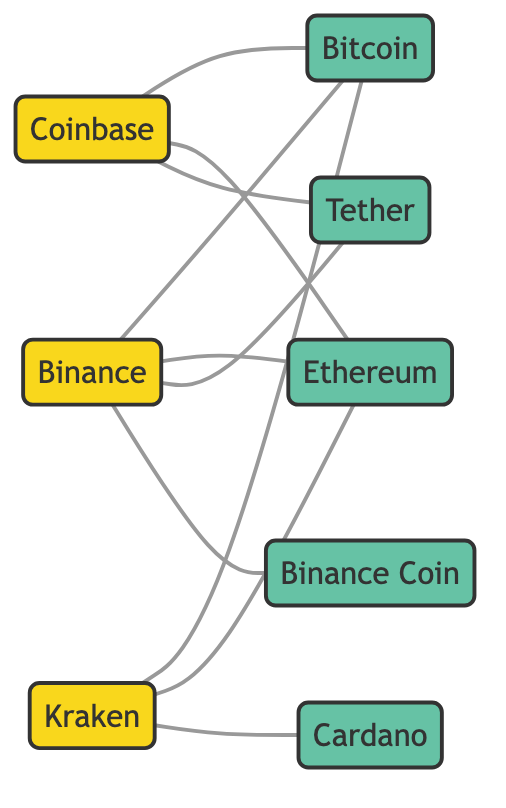What are the total number of exchanges shown in the diagram? By counting the nodes labeled as exchanges, I can see that there are three: Binance, Coinbase, and Kraken.
Answer: 3 Which crypto asset is supported by both Binance and Coinbase? Looking at the edges, Bitcoin and Ethereum are connected to both Binance and Coinbase. Since the question asks for one answer, I'll choose Bitcoin, as it's a common cryptocurrency often recognized by most exchanges.
Answer: Bitcoin How many edges are connected to Binance? To find the number of edges, I count the lines emerging from the Binance node. There are four connections: Bitcoin, Ethereum, Tether, and Binance Coin.
Answer: 4 Which exchange does not support Cardano? I check the connections for each exchange; Binance and Coinbase do not have any edge to Cardano. However, Kraken is the only exchange supporting Cardano. Therefore, both Binance and Coinbase do not support it. Since the question asks for a single exchange, I'll choose Binance.
Answer: Binance Which is the only exchange that supports Cardano? Through the edges, I can see that Kraken is the only exchange that has an edge connecting it to Cardano.
Answer: Kraken How many cryptocurrency assets are supported by Kraken? Reviewing the edges from the Kraken node, it connects to Bitcoin, Ethereum, and Cardano, totaling three crypto assets supported by Kraken.
Answer: 3 What type of relationship connects Binance and Tether? The relationship between Binance and Tether is labeled as "Supports" in the edge connecting them, indicating the nature of the connection.
Answer: Supports Which cryptocurrency asset is mentioned the most across the exchanges? I analyze the connections of each node and see that Bitcoin is supported by all three exchanges (Binance, Coinbase, and Kraken), thus being the most mentioned asset.
Answer: Bitcoin How many crypto assets are shown in the diagram? By counting the nodes that are categorized as crypto assets, I see there are five: Ethereum, Bitcoin, Tether, Binance Coin, and Cardano.
Answer: 5 